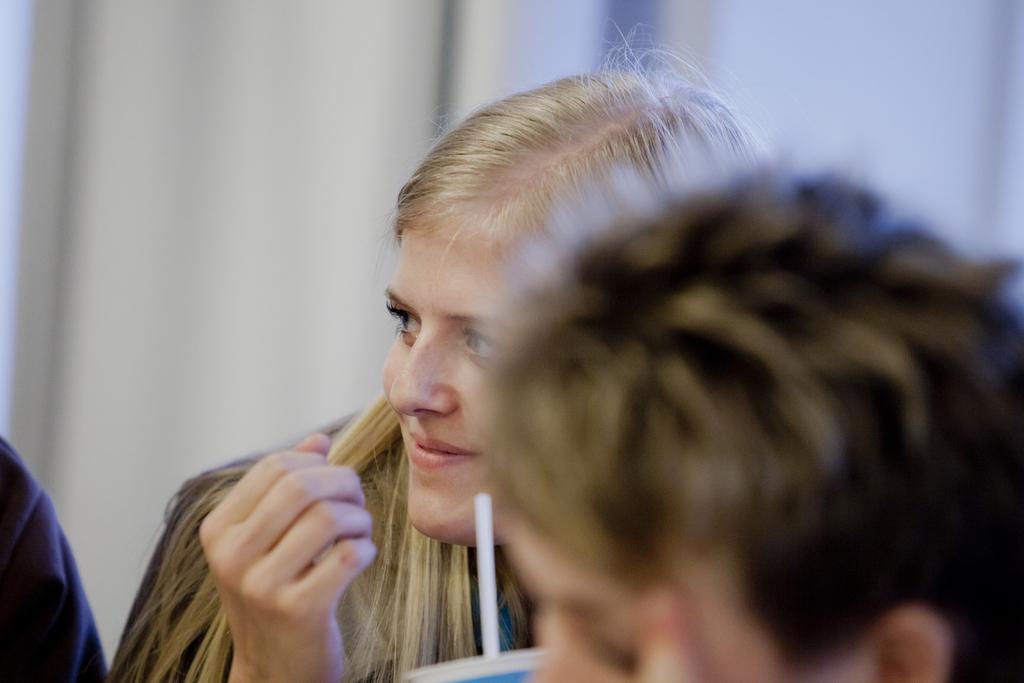Please provide a concise description of this image. In this image in the foreground there is one person, and in the background there is another person and she is holding a cup. And in the background there is a curtain, and on the left side there is another person's hand is visible. 